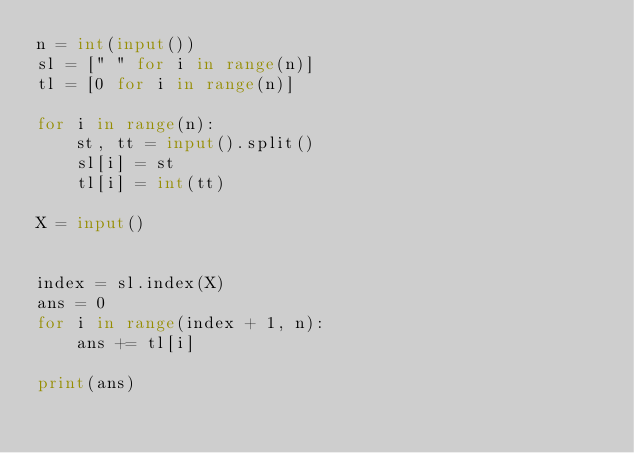Convert code to text. <code><loc_0><loc_0><loc_500><loc_500><_Python_>n = int(input())
sl = [" " for i in range(n)]
tl = [0 for i in range(n)]

for i in range(n):
    st, tt = input().split()
    sl[i] = st
    tl[i] = int(tt)

X = input()


index = sl.index(X)
ans = 0
for i in range(index + 1, n):
    ans += tl[i]

print(ans)
</code> 